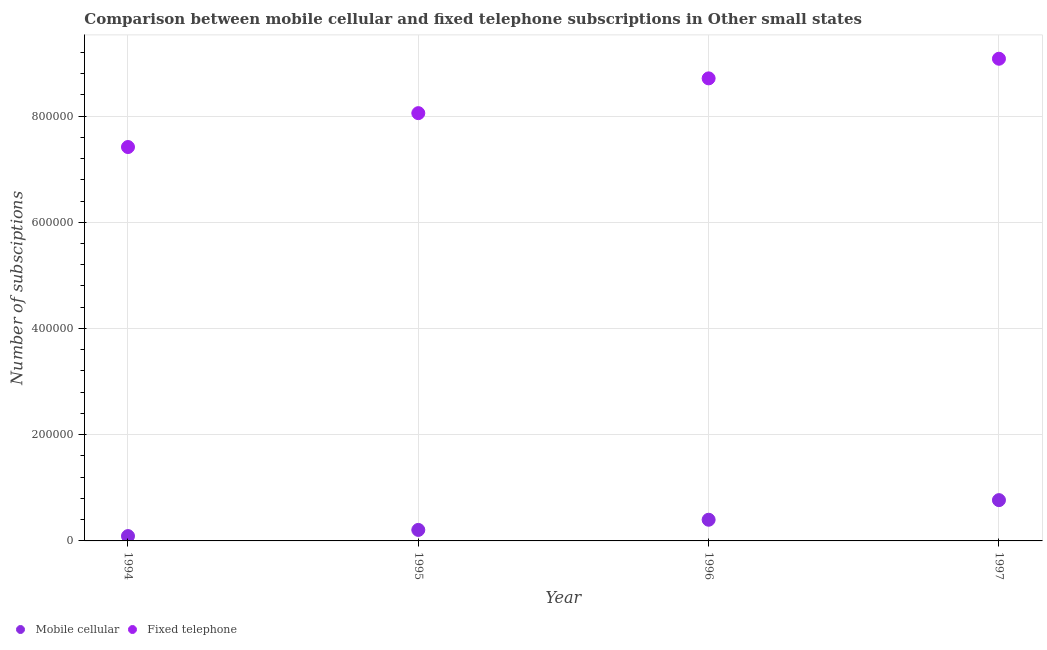What is the number of mobile cellular subscriptions in 1997?
Provide a succinct answer. 7.68e+04. Across all years, what is the maximum number of fixed telephone subscriptions?
Your response must be concise. 9.08e+05. Across all years, what is the minimum number of fixed telephone subscriptions?
Your answer should be compact. 7.42e+05. What is the total number of mobile cellular subscriptions in the graph?
Make the answer very short. 1.47e+05. What is the difference between the number of fixed telephone subscriptions in 1994 and that in 1996?
Provide a short and direct response. -1.29e+05. What is the difference between the number of fixed telephone subscriptions in 1994 and the number of mobile cellular subscriptions in 1995?
Your response must be concise. 7.21e+05. What is the average number of fixed telephone subscriptions per year?
Your answer should be compact. 8.31e+05. In the year 1995, what is the difference between the number of fixed telephone subscriptions and number of mobile cellular subscriptions?
Keep it short and to the point. 7.85e+05. In how many years, is the number of mobile cellular subscriptions greater than 360000?
Your response must be concise. 0. What is the ratio of the number of fixed telephone subscriptions in 1994 to that in 1997?
Ensure brevity in your answer.  0.82. Is the difference between the number of mobile cellular subscriptions in 1994 and 1997 greater than the difference between the number of fixed telephone subscriptions in 1994 and 1997?
Keep it short and to the point. Yes. What is the difference between the highest and the second highest number of mobile cellular subscriptions?
Ensure brevity in your answer.  3.69e+04. What is the difference between the highest and the lowest number of mobile cellular subscriptions?
Give a very brief answer. 6.77e+04. Is the sum of the number of mobile cellular subscriptions in 1995 and 1996 greater than the maximum number of fixed telephone subscriptions across all years?
Provide a short and direct response. No. Does the number of fixed telephone subscriptions monotonically increase over the years?
Your response must be concise. Yes. Is the number of fixed telephone subscriptions strictly greater than the number of mobile cellular subscriptions over the years?
Provide a short and direct response. Yes. How many dotlines are there?
Provide a short and direct response. 2. How many years are there in the graph?
Ensure brevity in your answer.  4. Are the values on the major ticks of Y-axis written in scientific E-notation?
Keep it short and to the point. No. Does the graph contain any zero values?
Ensure brevity in your answer.  No. How are the legend labels stacked?
Make the answer very short. Horizontal. What is the title of the graph?
Offer a very short reply. Comparison between mobile cellular and fixed telephone subscriptions in Other small states. Does "Money lenders" appear as one of the legend labels in the graph?
Your answer should be compact. No. What is the label or title of the X-axis?
Your answer should be very brief. Year. What is the label or title of the Y-axis?
Offer a terse response. Number of subsciptions. What is the Number of subsciptions of Mobile cellular in 1994?
Provide a short and direct response. 9099. What is the Number of subsciptions of Fixed telephone in 1994?
Make the answer very short. 7.42e+05. What is the Number of subsciptions of Mobile cellular in 1995?
Your answer should be compact. 2.07e+04. What is the Number of subsciptions in Fixed telephone in 1995?
Your answer should be very brief. 8.05e+05. What is the Number of subsciptions in Mobile cellular in 1996?
Provide a short and direct response. 3.99e+04. What is the Number of subsciptions of Fixed telephone in 1996?
Ensure brevity in your answer.  8.71e+05. What is the Number of subsciptions of Mobile cellular in 1997?
Your answer should be compact. 7.68e+04. What is the Number of subsciptions of Fixed telephone in 1997?
Provide a succinct answer. 9.08e+05. Across all years, what is the maximum Number of subsciptions of Mobile cellular?
Make the answer very short. 7.68e+04. Across all years, what is the maximum Number of subsciptions in Fixed telephone?
Offer a terse response. 9.08e+05. Across all years, what is the minimum Number of subsciptions in Mobile cellular?
Your answer should be compact. 9099. Across all years, what is the minimum Number of subsciptions of Fixed telephone?
Make the answer very short. 7.42e+05. What is the total Number of subsciptions in Mobile cellular in the graph?
Make the answer very short. 1.47e+05. What is the total Number of subsciptions of Fixed telephone in the graph?
Keep it short and to the point. 3.33e+06. What is the difference between the Number of subsciptions of Mobile cellular in 1994 and that in 1995?
Ensure brevity in your answer.  -1.16e+04. What is the difference between the Number of subsciptions in Fixed telephone in 1994 and that in 1995?
Offer a very short reply. -6.38e+04. What is the difference between the Number of subsciptions of Mobile cellular in 1994 and that in 1996?
Give a very brief answer. -3.08e+04. What is the difference between the Number of subsciptions of Fixed telephone in 1994 and that in 1996?
Offer a very short reply. -1.29e+05. What is the difference between the Number of subsciptions in Mobile cellular in 1994 and that in 1997?
Provide a short and direct response. -6.77e+04. What is the difference between the Number of subsciptions in Fixed telephone in 1994 and that in 1997?
Your response must be concise. -1.66e+05. What is the difference between the Number of subsciptions in Mobile cellular in 1995 and that in 1996?
Your response must be concise. -1.92e+04. What is the difference between the Number of subsciptions in Fixed telephone in 1995 and that in 1996?
Ensure brevity in your answer.  -6.55e+04. What is the difference between the Number of subsciptions in Mobile cellular in 1995 and that in 1997?
Your response must be concise. -5.61e+04. What is the difference between the Number of subsciptions in Fixed telephone in 1995 and that in 1997?
Provide a short and direct response. -1.02e+05. What is the difference between the Number of subsciptions of Mobile cellular in 1996 and that in 1997?
Your answer should be very brief. -3.69e+04. What is the difference between the Number of subsciptions in Fixed telephone in 1996 and that in 1997?
Keep it short and to the point. -3.70e+04. What is the difference between the Number of subsciptions in Mobile cellular in 1994 and the Number of subsciptions in Fixed telephone in 1995?
Offer a very short reply. -7.96e+05. What is the difference between the Number of subsciptions of Mobile cellular in 1994 and the Number of subsciptions of Fixed telephone in 1996?
Offer a terse response. -8.62e+05. What is the difference between the Number of subsciptions of Mobile cellular in 1994 and the Number of subsciptions of Fixed telephone in 1997?
Offer a very short reply. -8.99e+05. What is the difference between the Number of subsciptions of Mobile cellular in 1995 and the Number of subsciptions of Fixed telephone in 1996?
Give a very brief answer. -8.50e+05. What is the difference between the Number of subsciptions of Mobile cellular in 1995 and the Number of subsciptions of Fixed telephone in 1997?
Your answer should be compact. -8.87e+05. What is the difference between the Number of subsciptions in Mobile cellular in 1996 and the Number of subsciptions in Fixed telephone in 1997?
Provide a short and direct response. -8.68e+05. What is the average Number of subsciptions of Mobile cellular per year?
Your answer should be compact. 3.66e+04. What is the average Number of subsciptions of Fixed telephone per year?
Offer a very short reply. 8.31e+05. In the year 1994, what is the difference between the Number of subsciptions of Mobile cellular and Number of subsciptions of Fixed telephone?
Provide a short and direct response. -7.33e+05. In the year 1995, what is the difference between the Number of subsciptions of Mobile cellular and Number of subsciptions of Fixed telephone?
Your answer should be compact. -7.85e+05. In the year 1996, what is the difference between the Number of subsciptions of Mobile cellular and Number of subsciptions of Fixed telephone?
Provide a short and direct response. -8.31e+05. In the year 1997, what is the difference between the Number of subsciptions of Mobile cellular and Number of subsciptions of Fixed telephone?
Offer a terse response. -8.31e+05. What is the ratio of the Number of subsciptions of Mobile cellular in 1994 to that in 1995?
Your response must be concise. 0.44. What is the ratio of the Number of subsciptions in Fixed telephone in 1994 to that in 1995?
Make the answer very short. 0.92. What is the ratio of the Number of subsciptions in Mobile cellular in 1994 to that in 1996?
Provide a short and direct response. 0.23. What is the ratio of the Number of subsciptions of Fixed telephone in 1994 to that in 1996?
Your answer should be compact. 0.85. What is the ratio of the Number of subsciptions in Mobile cellular in 1994 to that in 1997?
Your answer should be compact. 0.12. What is the ratio of the Number of subsciptions of Fixed telephone in 1994 to that in 1997?
Keep it short and to the point. 0.82. What is the ratio of the Number of subsciptions in Mobile cellular in 1995 to that in 1996?
Provide a short and direct response. 0.52. What is the ratio of the Number of subsciptions in Fixed telephone in 1995 to that in 1996?
Offer a very short reply. 0.92. What is the ratio of the Number of subsciptions of Mobile cellular in 1995 to that in 1997?
Ensure brevity in your answer.  0.27. What is the ratio of the Number of subsciptions of Fixed telephone in 1995 to that in 1997?
Your answer should be very brief. 0.89. What is the ratio of the Number of subsciptions of Mobile cellular in 1996 to that in 1997?
Provide a succinct answer. 0.52. What is the ratio of the Number of subsciptions in Fixed telephone in 1996 to that in 1997?
Your answer should be compact. 0.96. What is the difference between the highest and the second highest Number of subsciptions in Mobile cellular?
Your response must be concise. 3.69e+04. What is the difference between the highest and the second highest Number of subsciptions in Fixed telephone?
Keep it short and to the point. 3.70e+04. What is the difference between the highest and the lowest Number of subsciptions in Mobile cellular?
Provide a short and direct response. 6.77e+04. What is the difference between the highest and the lowest Number of subsciptions of Fixed telephone?
Make the answer very short. 1.66e+05. 